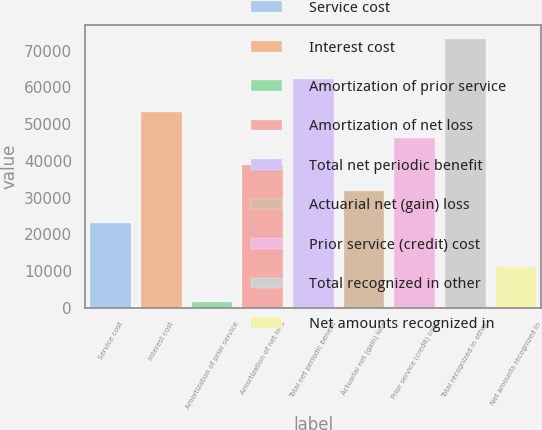<chart> <loc_0><loc_0><loc_500><loc_500><bar_chart><fcel>Service cost<fcel>Interest cost<fcel>Amortization of prior service<fcel>Amortization of net loss<fcel>Total net periodic benefit<fcel>Actuarial net (gain) loss<fcel>Prior service (credit) cost<fcel>Total recognized in other<fcel>Net amounts recognized in<nl><fcel>23075<fcel>53292.2<fcel>1555<fcel>38945.4<fcel>62172<fcel>31772<fcel>46118.8<fcel>73289<fcel>11117<nl></chart> 